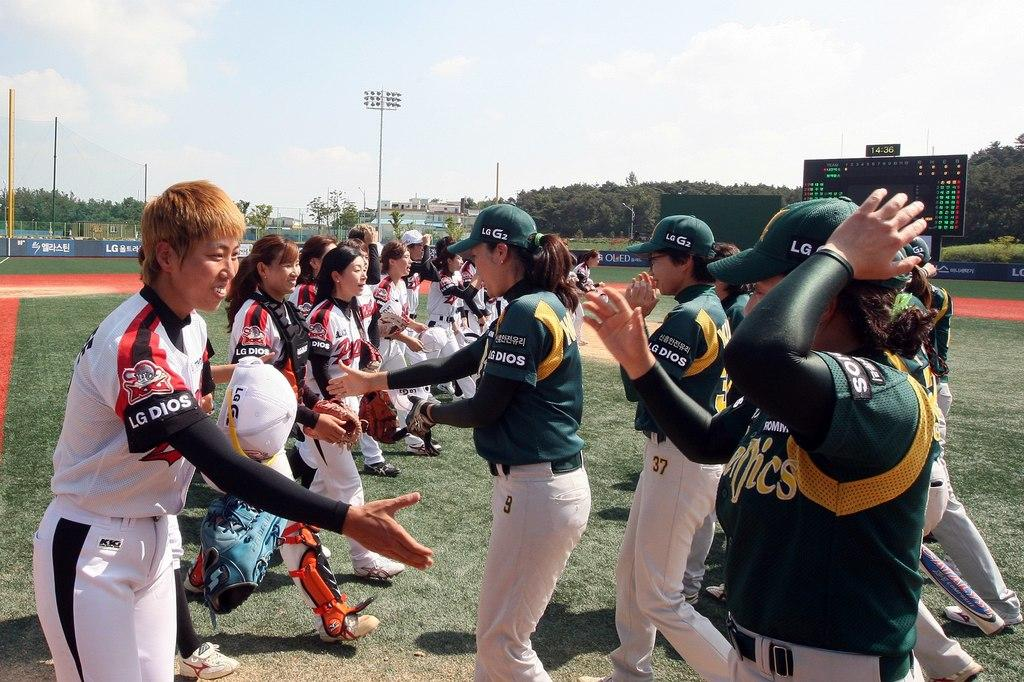<image>
Present a compact description of the photo's key features. Two softball teams shaking hands, one with a white jersey that says LG Dios 